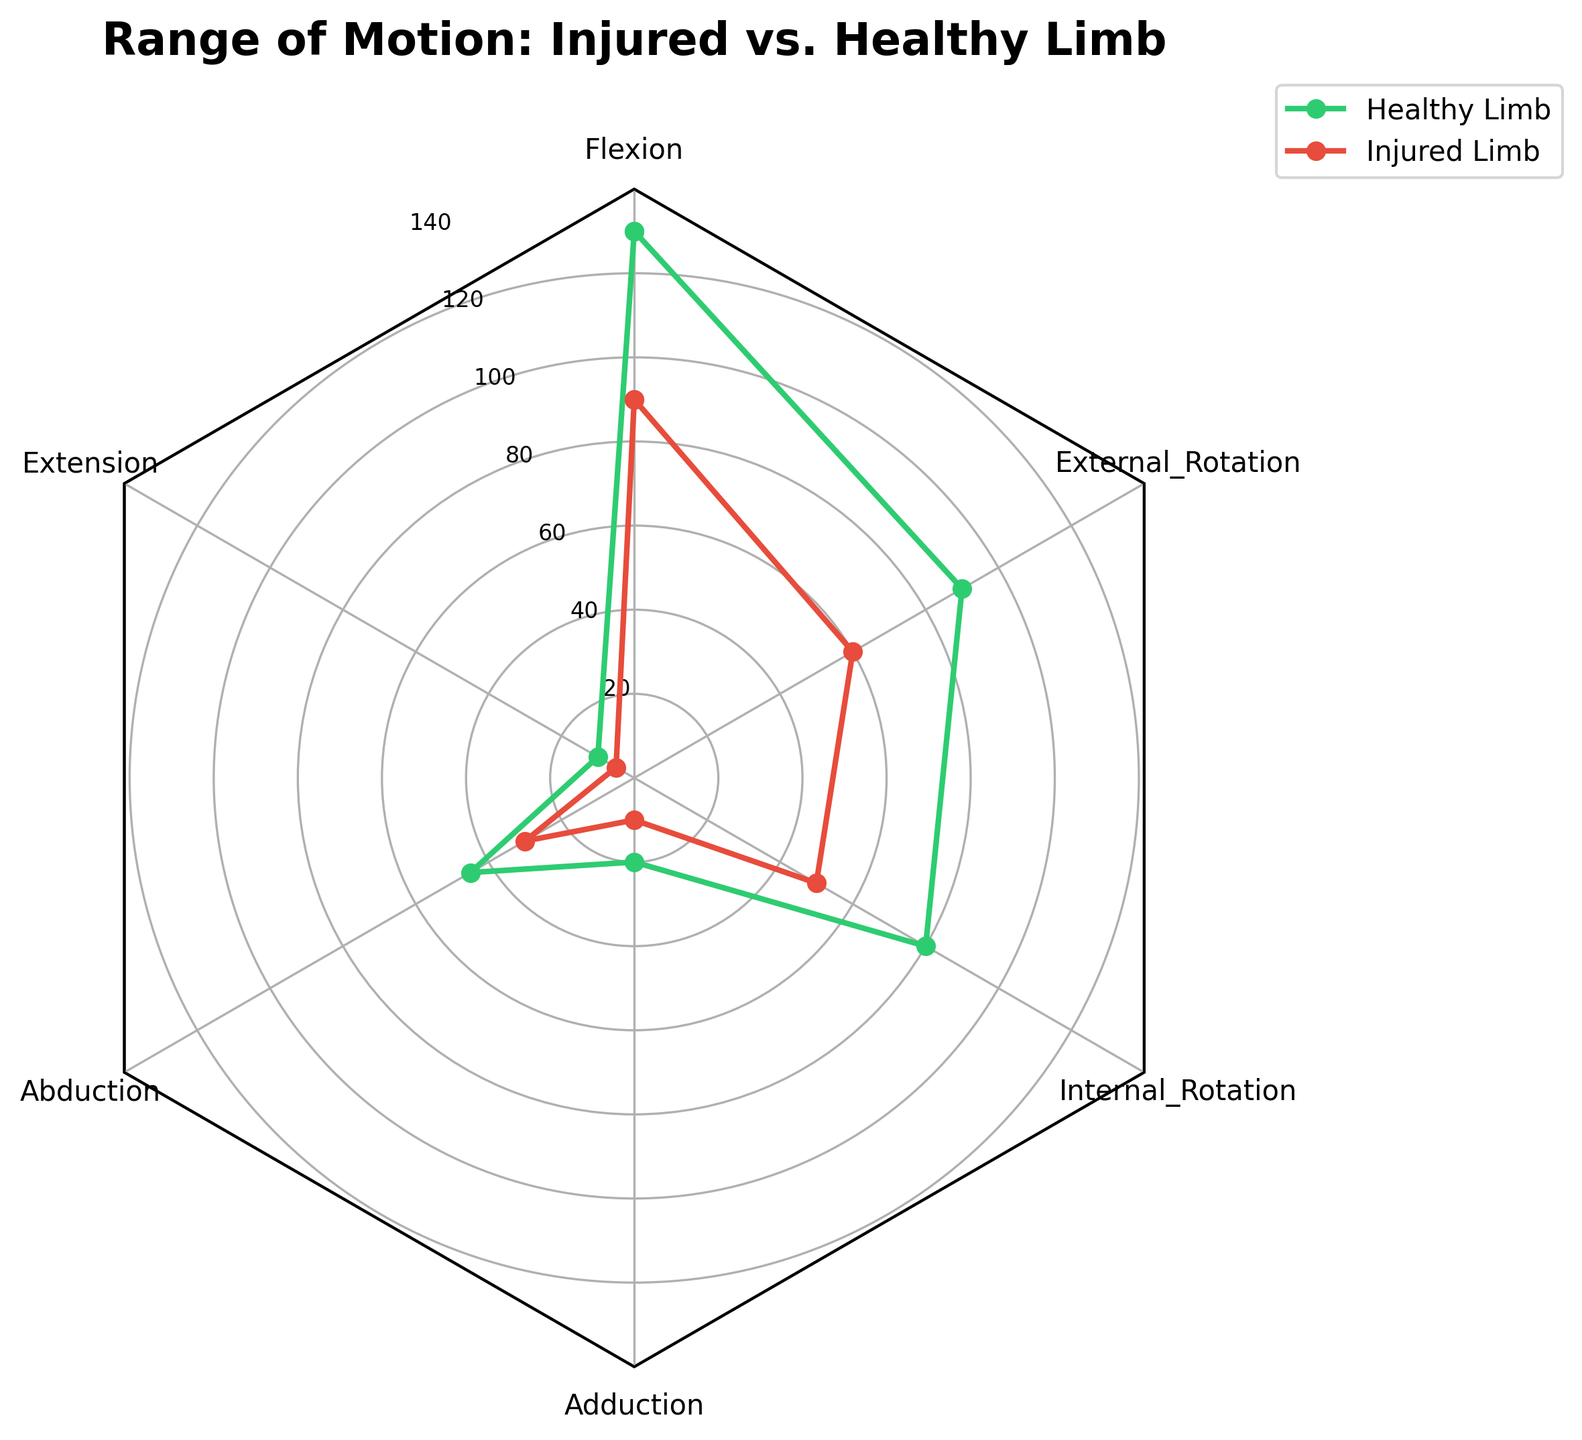What is the title of the radar chart? The title of the radar chart is usually placed at the top and in bold text. According to the provided data in the code, the title is "Range of Motion: Injured vs. Healthy Limb".
Answer: Range of Motion: Injured vs. Healthy Limb How many categories are compared in the chart? To determine the number of categories, we look at the number of axis labels around the radar chart. These correspond to the different angles of the plot. In this case, there are six categories: Flexion, Extension, Abduction, Adduction, Internal Rotation, and External Rotation.
Answer: Six Which limb has a higher range of motion for Flexion? To find the range of motion for Flexion for both limbs, we look at the values on the radar chart. The Healthy Limb is represented by the green line and the Injured Limb by the red line. The Flexion points have values 130 for the Healthy Limb and 90 for the Injured Limb. 130 is greater than 90.
Answer: Healthy Limb What is the difference in range of motion for Abduction between the Healthy and Injured limbs? To find the difference, we look at the radar chart's Abduction value for both limbs. The Healthy Limb has an Abduction value of 45, and the Injured Limb has a value of 30. Subtract the smaller number from the larger one: 45 - 30 = 15.
Answer: 15 In which category is the difference between the Healthy and Injured limbs most significant? To determine where the biggest difference is, we need to compare the differences in each category. The differences are:
- Flexion: 130 - 90 = 40
- Extension: 10 - 5 = 5
- Abduction: 45 - 30 = 15
- Adduction: 20 - 10 = 10
- Internal Rotation: 80 - 50 = 30
- External Rotation: 90 - 60 = 30
The largest difference is for Flexion, which is 40.
Answer: Flexion Which has a greater range of motion for Internal Rotation, the Healthy Limb or the Injured Limb? By examining the radar chart at the Internal Rotation category, we see that the value for the Healthy Limb (green line) is 80, while the value for the Injured Limb (red line) is 50. 80 is greater than 50.
Answer: Healthy Limb What is the average range of motion for the Healthy Limb across all categories? To calculate the average range of motion for the Healthy Limb, sum the values for each category (130, 10, 45, 20, 80, 90) and divide by the number of categories (6). This gives: (130 + 10 + 45 + 20 + 80 + 90) / 6 = 375 / 6 = 62.5.
Answer: 62.5 Is the range of motion for Extension higher in the Healthy Limb or the Injured Limb? Check the Extension values on the radar chart. The Healthy Limb has an Extension value of 10, while the Injured Limb has a value of 5. 10 is greater than 5.
Answer: Healthy Limb What are the y-axis tick intervals on the radar chart? The y-axis tick intervals indicate the scale on the radar chart. According to the data provided for setting the ticks, the chart has intervals of 20, so they are 20, 40, 60, 80, 100, 120, and 140.
Answer: 20 